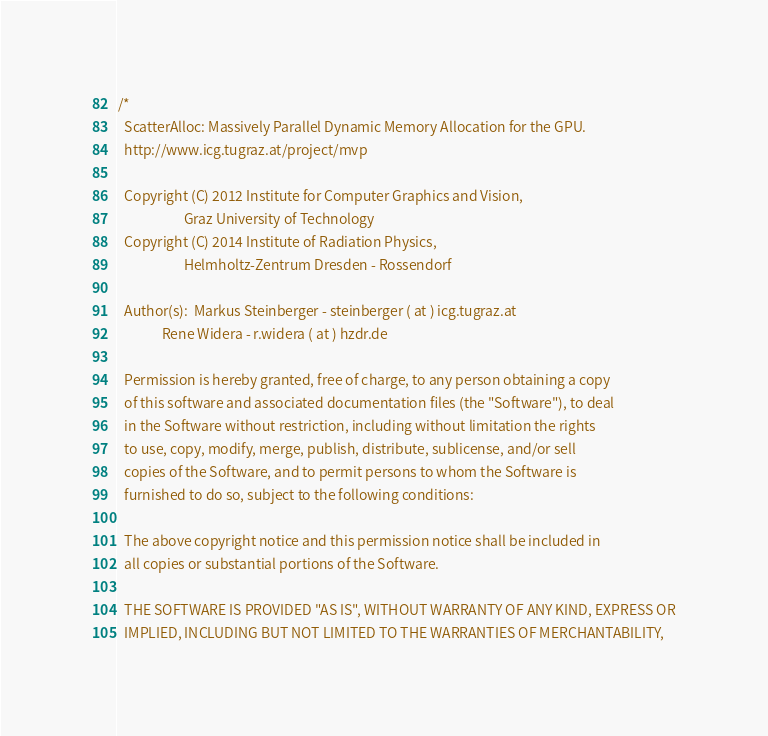Convert code to text. <code><loc_0><loc_0><loc_500><loc_500><_Cuda_>/*
  ScatterAlloc: Massively Parallel Dynamic Memory Allocation for the GPU.
  http://www.icg.tugraz.at/project/mvp

  Copyright (C) 2012 Institute for Computer Graphics and Vision,
                     Graz University of Technology
  Copyright (C) 2014 Institute of Radiation Physics,
                     Helmholtz-Zentrum Dresden - Rossendorf

  Author(s):  Markus Steinberger - steinberger ( at ) icg.tugraz.at
              Rene Widera - r.widera ( at ) hzdr.de

  Permission is hereby granted, free of charge, to any person obtaining a copy
  of this software and associated documentation files (the "Software"), to deal
  in the Software without restriction, including without limitation the rights
  to use, copy, modify, merge, publish, distribute, sublicense, and/or sell
  copies of the Software, and to permit persons to whom the Software is
  furnished to do so, subject to the following conditions:

  The above copyright notice and this permission notice shall be included in
  all copies or substantial portions of the Software.

  THE SOFTWARE IS PROVIDED "AS IS", WITHOUT WARRANTY OF ANY KIND, EXPRESS OR
  IMPLIED, INCLUDING BUT NOT LIMITED TO THE WARRANTIES OF MERCHANTABILITY,</code> 